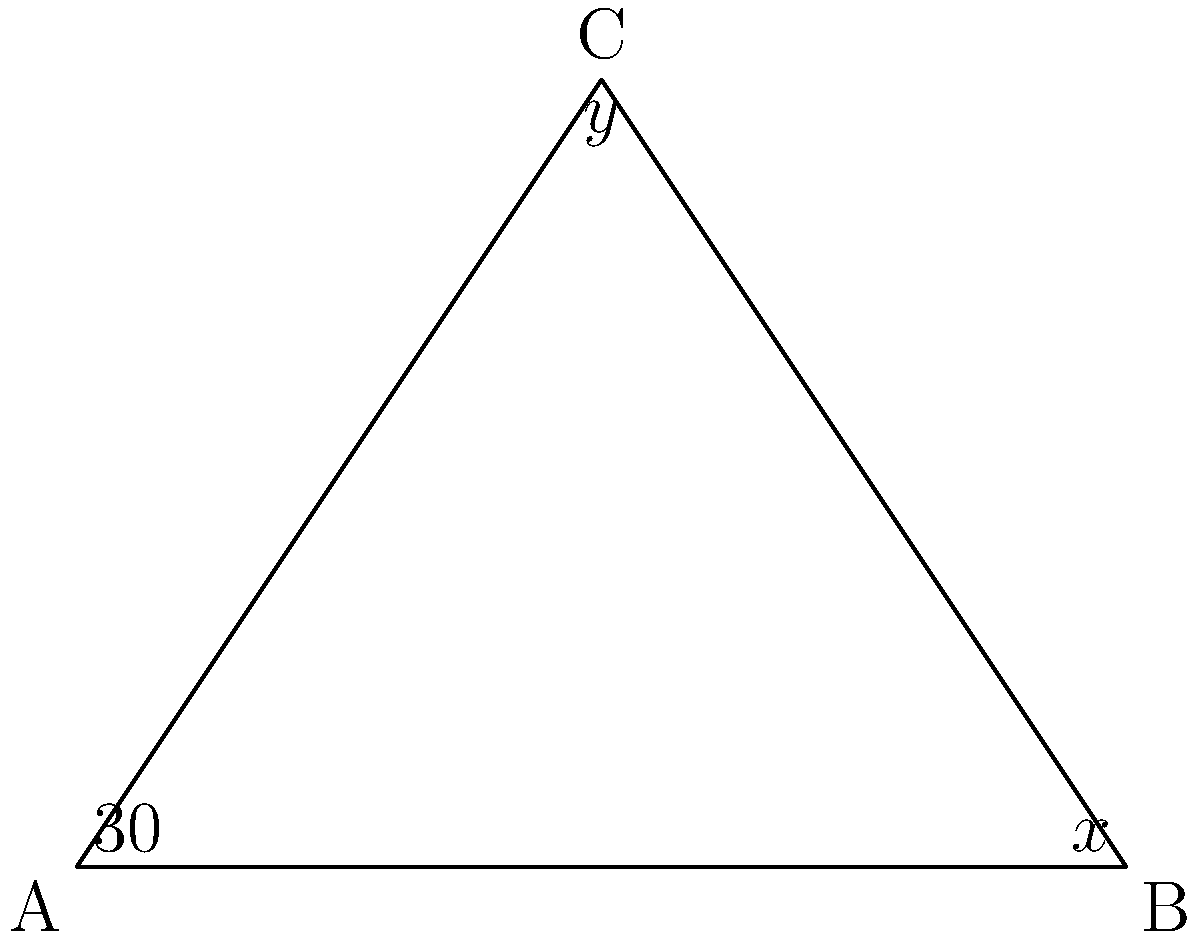In a unique triangular arrangement of organ keys inspired by the innovative designs of 18th-century organ builders, the keys form a triangle ABC. Given that angle A is 30°, and the sum of angles x and y is 120°, determine the value of angle x. Let's approach this step-by-step using the properties of triangles:

1) In any triangle, the sum of all interior angles is 180°. Therefore:

   $30° + x° + y° = 180°$

2) We're given that the sum of x and y is 120°:

   $x° + y° = 120°$

3) Substituting this into our first equation:

   $30° + 120° = 180°$

4) This confirms that our given information is consistent with the properties of triangles.

5) To find x, we can use the fact that $x° + y° = 120°$

6) Since we need to find x, let's express y in terms of x:

   $y° = 120° - x°$

7) Now, let's use our original triangle angle sum equation, substituting this expression for y:

   $30° + x° + (120° - x°) = 180°$

8) Simplify:

   $150° = 180°$

9) Subtract 150° from both sides:

   $x° = 30°$

Therefore, angle x is 30°.
Answer: $30°$ 